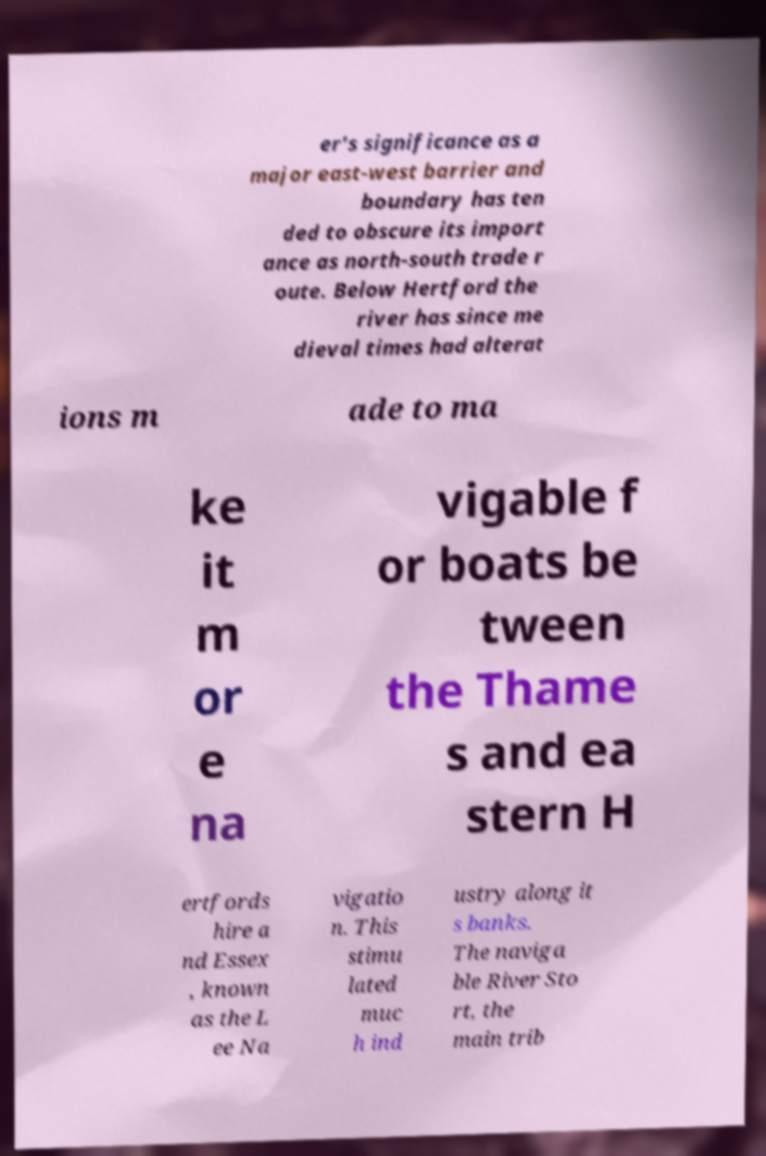I need the written content from this picture converted into text. Can you do that? er's significance as a major east-west barrier and boundary has ten ded to obscure its import ance as north-south trade r oute. Below Hertford the river has since me dieval times had alterat ions m ade to ma ke it m or e na vigable f or boats be tween the Thame s and ea stern H ertfords hire a nd Essex , known as the L ee Na vigatio n. This stimu lated muc h ind ustry along it s banks. The naviga ble River Sto rt, the main trib 